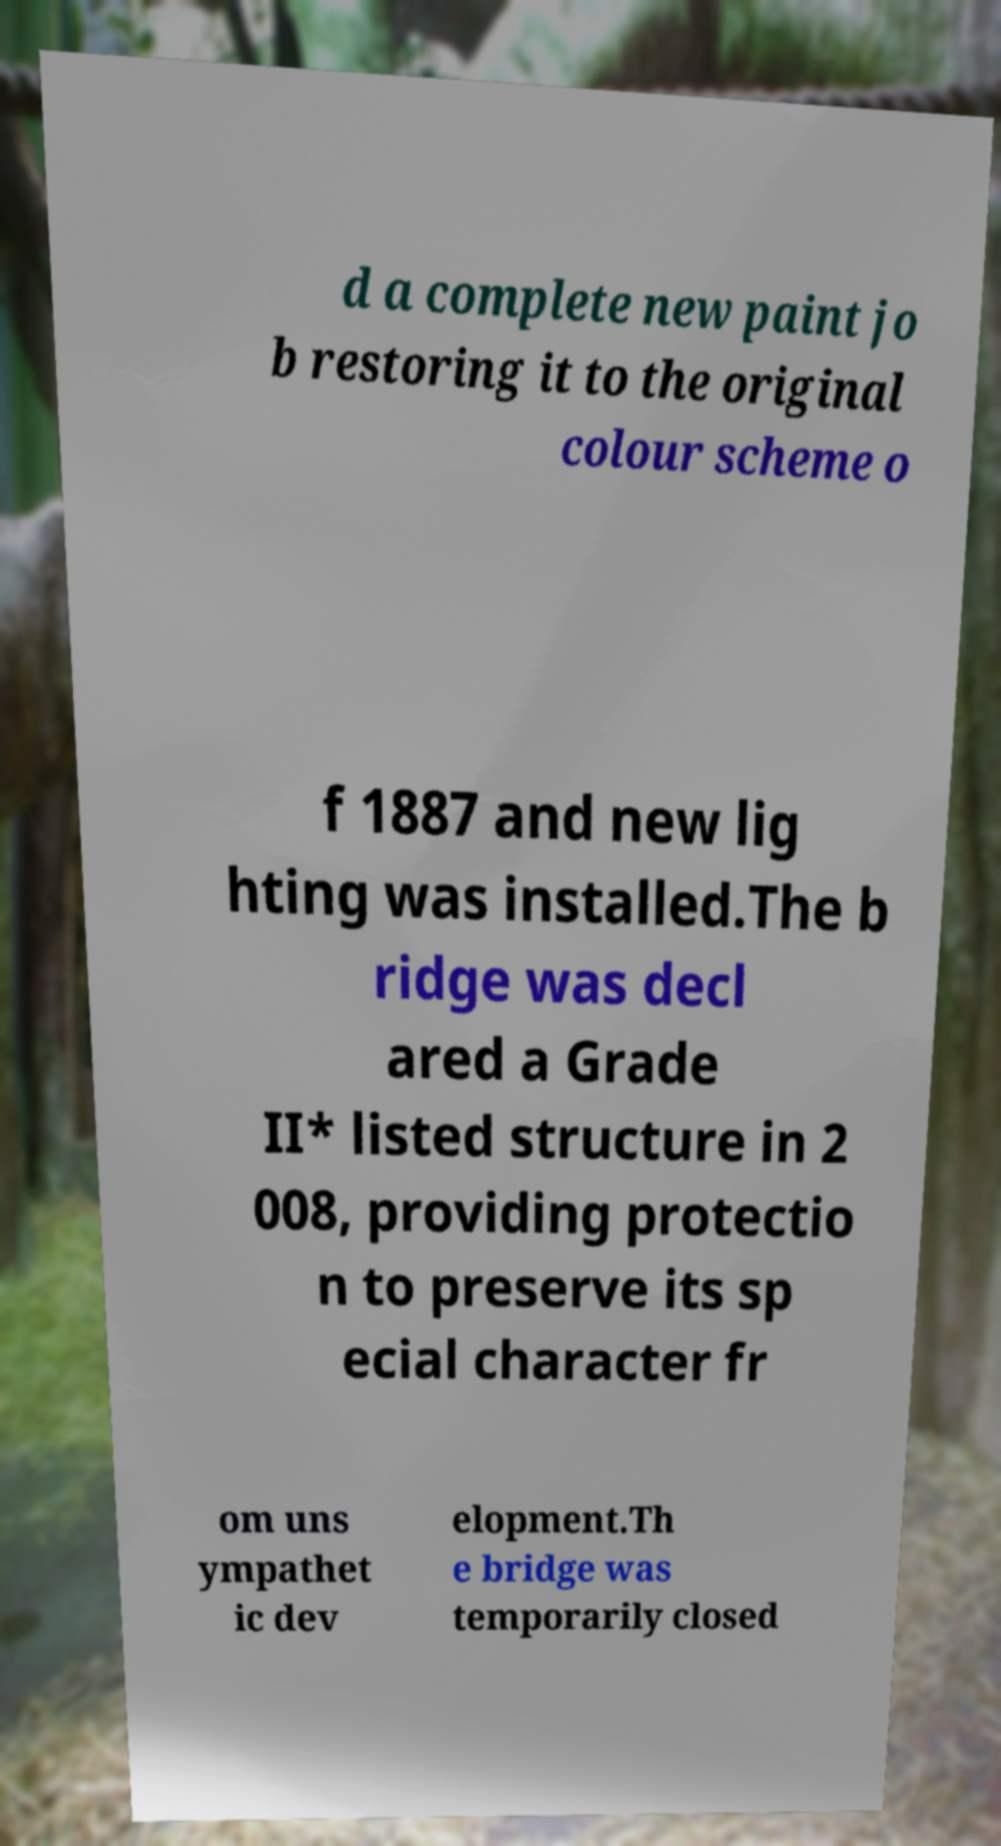Can you accurately transcribe the text from the provided image for me? d a complete new paint jo b restoring it to the original colour scheme o f 1887 and new lig hting was installed.The b ridge was decl ared a Grade II* listed structure in 2 008, providing protectio n to preserve its sp ecial character fr om uns ympathet ic dev elopment.Th e bridge was temporarily closed 